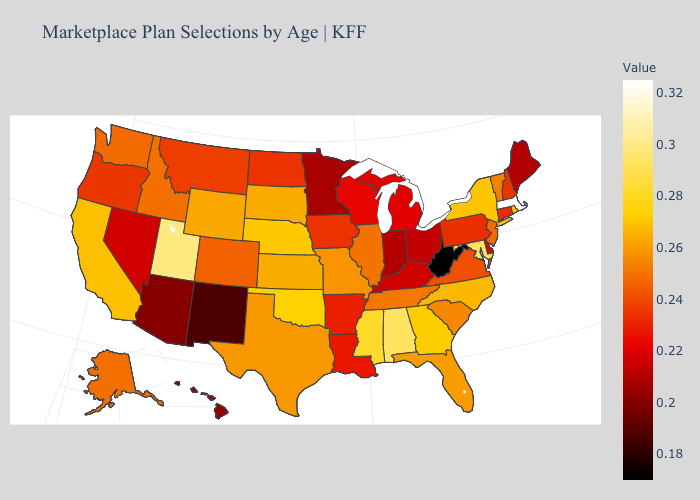Which states hav the highest value in the South?
Answer briefly. Alabama, Maryland. Does Nebraska have a higher value than Massachusetts?
Be succinct. No. Among the states that border Connecticut , which have the lowest value?
Keep it brief. New York. Does Arizona have the lowest value in the West?
Quick response, please. No. Does Massachusetts have the highest value in the USA?
Quick response, please. Yes. Does Massachusetts have the highest value in the USA?
Give a very brief answer. Yes. 